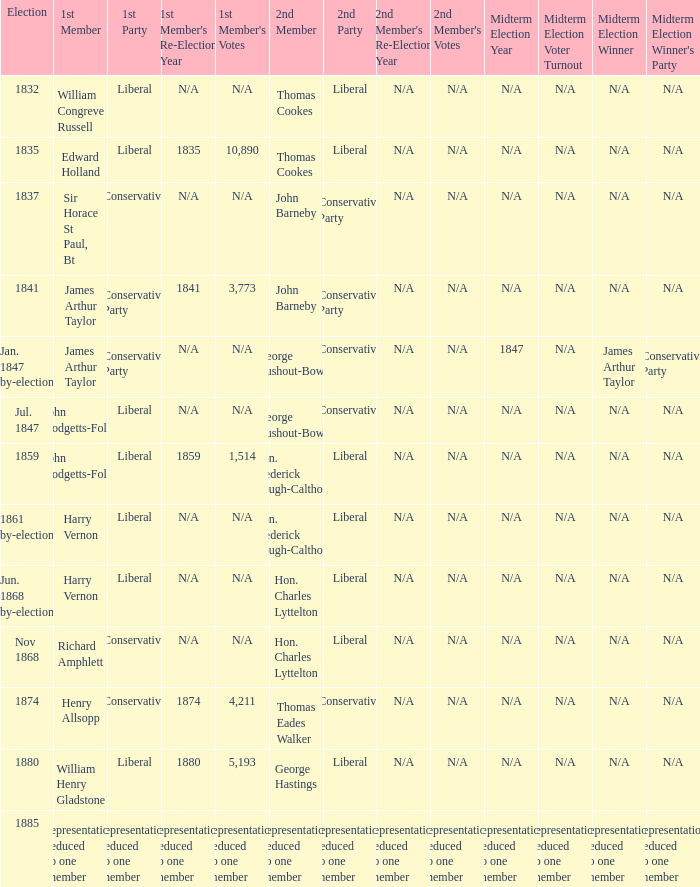What was the 2nd Party when its 2nd Member was George Rushout-Bowes, and the 1st Party was Liberal? Conservative. 